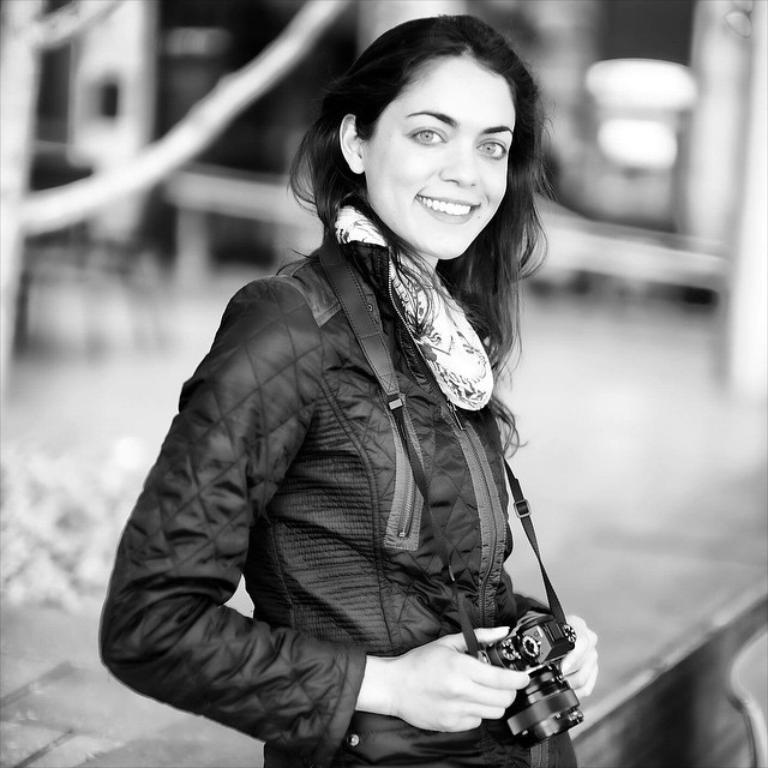Who is the main subject in the image? There is a woman in the picture. What is the woman doing in the image? The woman is standing and smiling. What is the woman holding in the image? The woman is holding a camera. How would you describe the background of the image? The background of the image is blurry. What is the color scheme of the image? The image is in black and white. What type of waves can be seen crashing on the shore in the image? There are no waves or shoreline present in the image; it features a woman standing and smiling while holding a camera. 